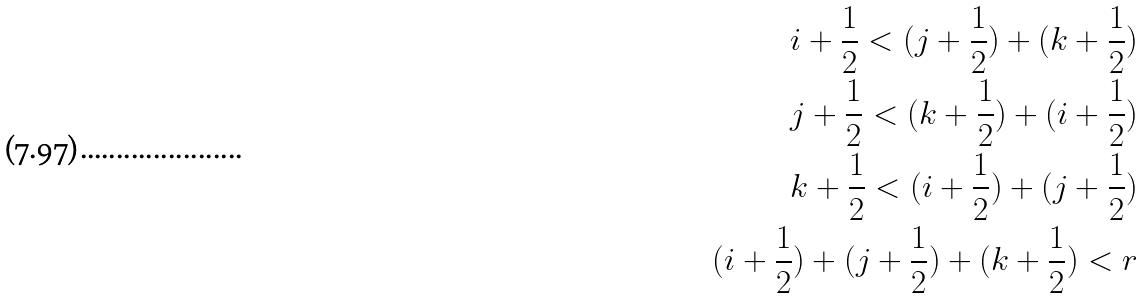Convert formula to latex. <formula><loc_0><loc_0><loc_500><loc_500>i + \frac { 1 } { 2 } < ( j + \frac { 1 } { 2 } ) + ( k + \frac { 1 } { 2 } ) \\ j + \frac { 1 } { 2 } < ( k + \frac { 1 } { 2 } ) + ( i + \frac { 1 } { 2 } ) \\ k + \frac { 1 } { 2 } < ( i + \frac { 1 } { 2 } ) + ( j + \frac { 1 } { 2 } ) \\ ( i + \frac { 1 } { 2 } ) + ( j + \frac { 1 } { 2 } ) + ( k + \frac { 1 } { 2 } ) < r</formula> 